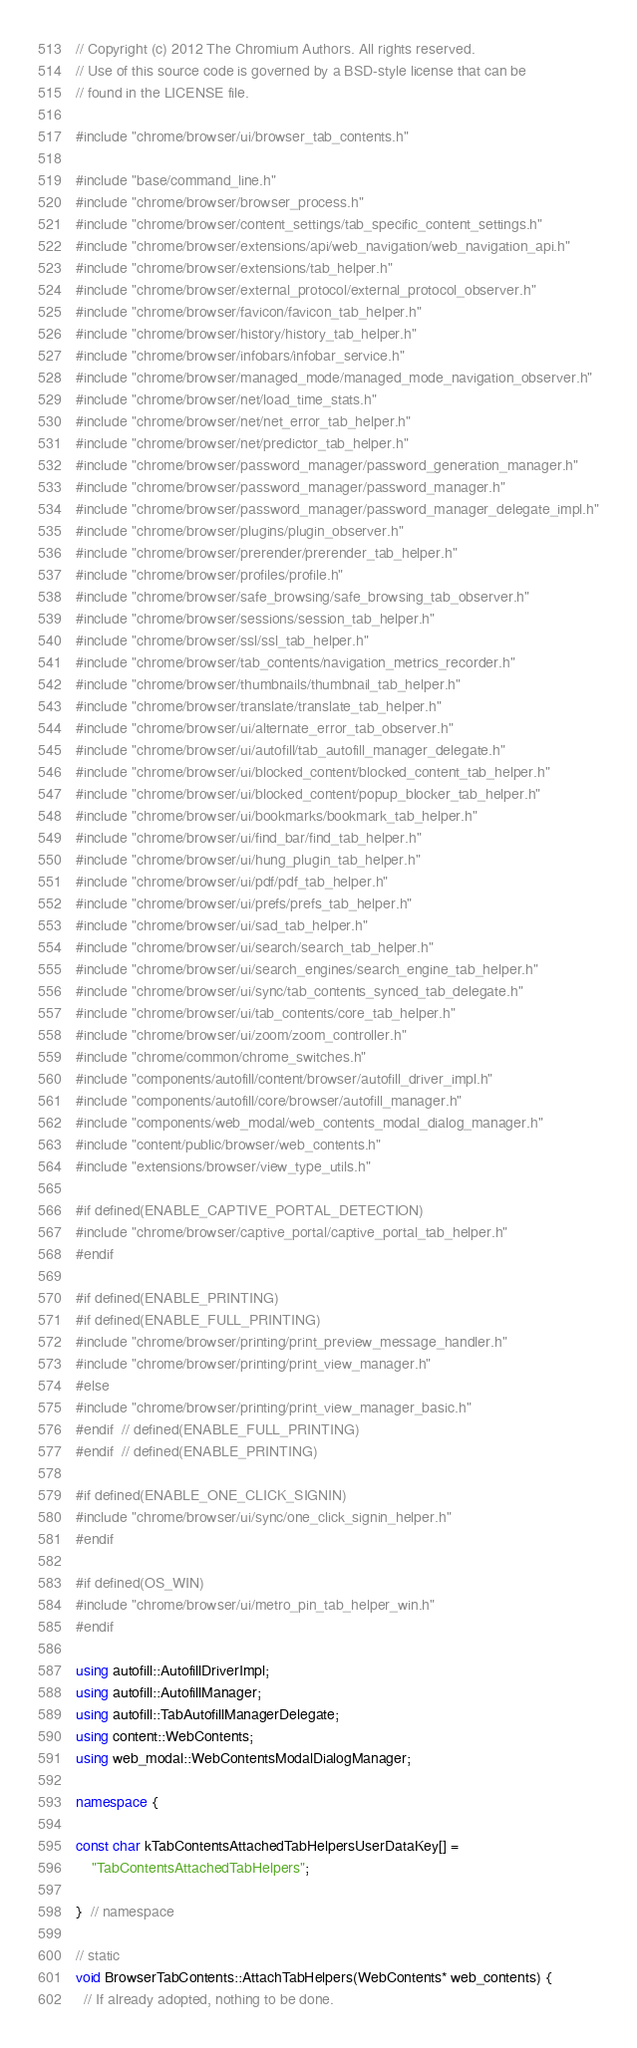Convert code to text. <code><loc_0><loc_0><loc_500><loc_500><_C++_>// Copyright (c) 2012 The Chromium Authors. All rights reserved.
// Use of this source code is governed by a BSD-style license that can be
// found in the LICENSE file.

#include "chrome/browser/ui/browser_tab_contents.h"

#include "base/command_line.h"
#include "chrome/browser/browser_process.h"
#include "chrome/browser/content_settings/tab_specific_content_settings.h"
#include "chrome/browser/extensions/api/web_navigation/web_navigation_api.h"
#include "chrome/browser/extensions/tab_helper.h"
#include "chrome/browser/external_protocol/external_protocol_observer.h"
#include "chrome/browser/favicon/favicon_tab_helper.h"
#include "chrome/browser/history/history_tab_helper.h"
#include "chrome/browser/infobars/infobar_service.h"
#include "chrome/browser/managed_mode/managed_mode_navigation_observer.h"
#include "chrome/browser/net/load_time_stats.h"
#include "chrome/browser/net/net_error_tab_helper.h"
#include "chrome/browser/net/predictor_tab_helper.h"
#include "chrome/browser/password_manager/password_generation_manager.h"
#include "chrome/browser/password_manager/password_manager.h"
#include "chrome/browser/password_manager/password_manager_delegate_impl.h"
#include "chrome/browser/plugins/plugin_observer.h"
#include "chrome/browser/prerender/prerender_tab_helper.h"
#include "chrome/browser/profiles/profile.h"
#include "chrome/browser/safe_browsing/safe_browsing_tab_observer.h"
#include "chrome/browser/sessions/session_tab_helper.h"
#include "chrome/browser/ssl/ssl_tab_helper.h"
#include "chrome/browser/tab_contents/navigation_metrics_recorder.h"
#include "chrome/browser/thumbnails/thumbnail_tab_helper.h"
#include "chrome/browser/translate/translate_tab_helper.h"
#include "chrome/browser/ui/alternate_error_tab_observer.h"
#include "chrome/browser/ui/autofill/tab_autofill_manager_delegate.h"
#include "chrome/browser/ui/blocked_content/blocked_content_tab_helper.h"
#include "chrome/browser/ui/blocked_content/popup_blocker_tab_helper.h"
#include "chrome/browser/ui/bookmarks/bookmark_tab_helper.h"
#include "chrome/browser/ui/find_bar/find_tab_helper.h"
#include "chrome/browser/ui/hung_plugin_tab_helper.h"
#include "chrome/browser/ui/pdf/pdf_tab_helper.h"
#include "chrome/browser/ui/prefs/prefs_tab_helper.h"
#include "chrome/browser/ui/sad_tab_helper.h"
#include "chrome/browser/ui/search/search_tab_helper.h"
#include "chrome/browser/ui/search_engines/search_engine_tab_helper.h"
#include "chrome/browser/ui/sync/tab_contents_synced_tab_delegate.h"
#include "chrome/browser/ui/tab_contents/core_tab_helper.h"
#include "chrome/browser/ui/zoom/zoom_controller.h"
#include "chrome/common/chrome_switches.h"
#include "components/autofill/content/browser/autofill_driver_impl.h"
#include "components/autofill/core/browser/autofill_manager.h"
#include "components/web_modal/web_contents_modal_dialog_manager.h"
#include "content/public/browser/web_contents.h"
#include "extensions/browser/view_type_utils.h"

#if defined(ENABLE_CAPTIVE_PORTAL_DETECTION)
#include "chrome/browser/captive_portal/captive_portal_tab_helper.h"
#endif

#if defined(ENABLE_PRINTING)
#if defined(ENABLE_FULL_PRINTING)
#include "chrome/browser/printing/print_preview_message_handler.h"
#include "chrome/browser/printing/print_view_manager.h"
#else
#include "chrome/browser/printing/print_view_manager_basic.h"
#endif  // defined(ENABLE_FULL_PRINTING)
#endif  // defined(ENABLE_PRINTING)

#if defined(ENABLE_ONE_CLICK_SIGNIN)
#include "chrome/browser/ui/sync/one_click_signin_helper.h"
#endif

#if defined(OS_WIN)
#include "chrome/browser/ui/metro_pin_tab_helper_win.h"
#endif

using autofill::AutofillDriverImpl;
using autofill::AutofillManager;
using autofill::TabAutofillManagerDelegate;
using content::WebContents;
using web_modal::WebContentsModalDialogManager;

namespace {

const char kTabContentsAttachedTabHelpersUserDataKey[] =
    "TabContentsAttachedTabHelpers";

}  // namespace

// static
void BrowserTabContents::AttachTabHelpers(WebContents* web_contents) {
  // If already adopted, nothing to be done.</code> 